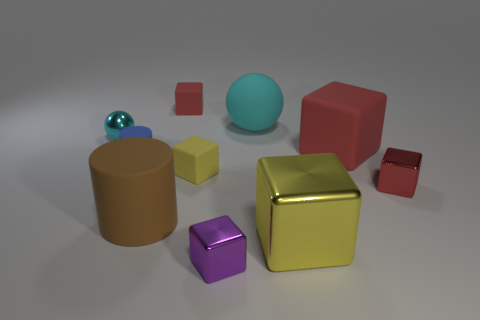What number of other things are there of the same size as the yellow metallic block?
Offer a terse response. 3. How big is the cyan thing that is in front of the big rubber object behind the small ball?
Ensure brevity in your answer.  Small. What number of big objects are either blocks or yellow rubber things?
Offer a terse response. 2. What size is the cylinder left of the large rubber thing that is in front of the rubber thing to the right of the large yellow cube?
Offer a very short reply. Small. Is there anything else that is the same color as the rubber ball?
Your answer should be very brief. Yes. The big thing behind the metallic thing behind the red cube that is in front of the tiny yellow rubber block is made of what material?
Provide a succinct answer. Rubber. Do the red metal object and the big brown matte thing have the same shape?
Your answer should be very brief. No. Is there any other thing that is the same material as the big ball?
Keep it short and to the point. Yes. What number of cyan objects are to the right of the small red matte cube and left of the rubber sphere?
Keep it short and to the point. 0. There is a large cylinder that is to the left of the red matte object that is in front of the tiny red rubber object; what is its color?
Ensure brevity in your answer.  Brown. 